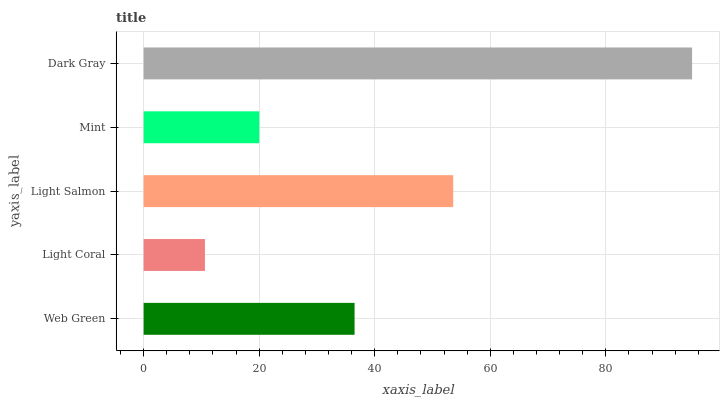Is Light Coral the minimum?
Answer yes or no. Yes. Is Dark Gray the maximum?
Answer yes or no. Yes. Is Light Salmon the minimum?
Answer yes or no. No. Is Light Salmon the maximum?
Answer yes or no. No. Is Light Salmon greater than Light Coral?
Answer yes or no. Yes. Is Light Coral less than Light Salmon?
Answer yes or no. Yes. Is Light Coral greater than Light Salmon?
Answer yes or no. No. Is Light Salmon less than Light Coral?
Answer yes or no. No. Is Web Green the high median?
Answer yes or no. Yes. Is Web Green the low median?
Answer yes or no. Yes. Is Light Coral the high median?
Answer yes or no. No. Is Light Coral the low median?
Answer yes or no. No. 